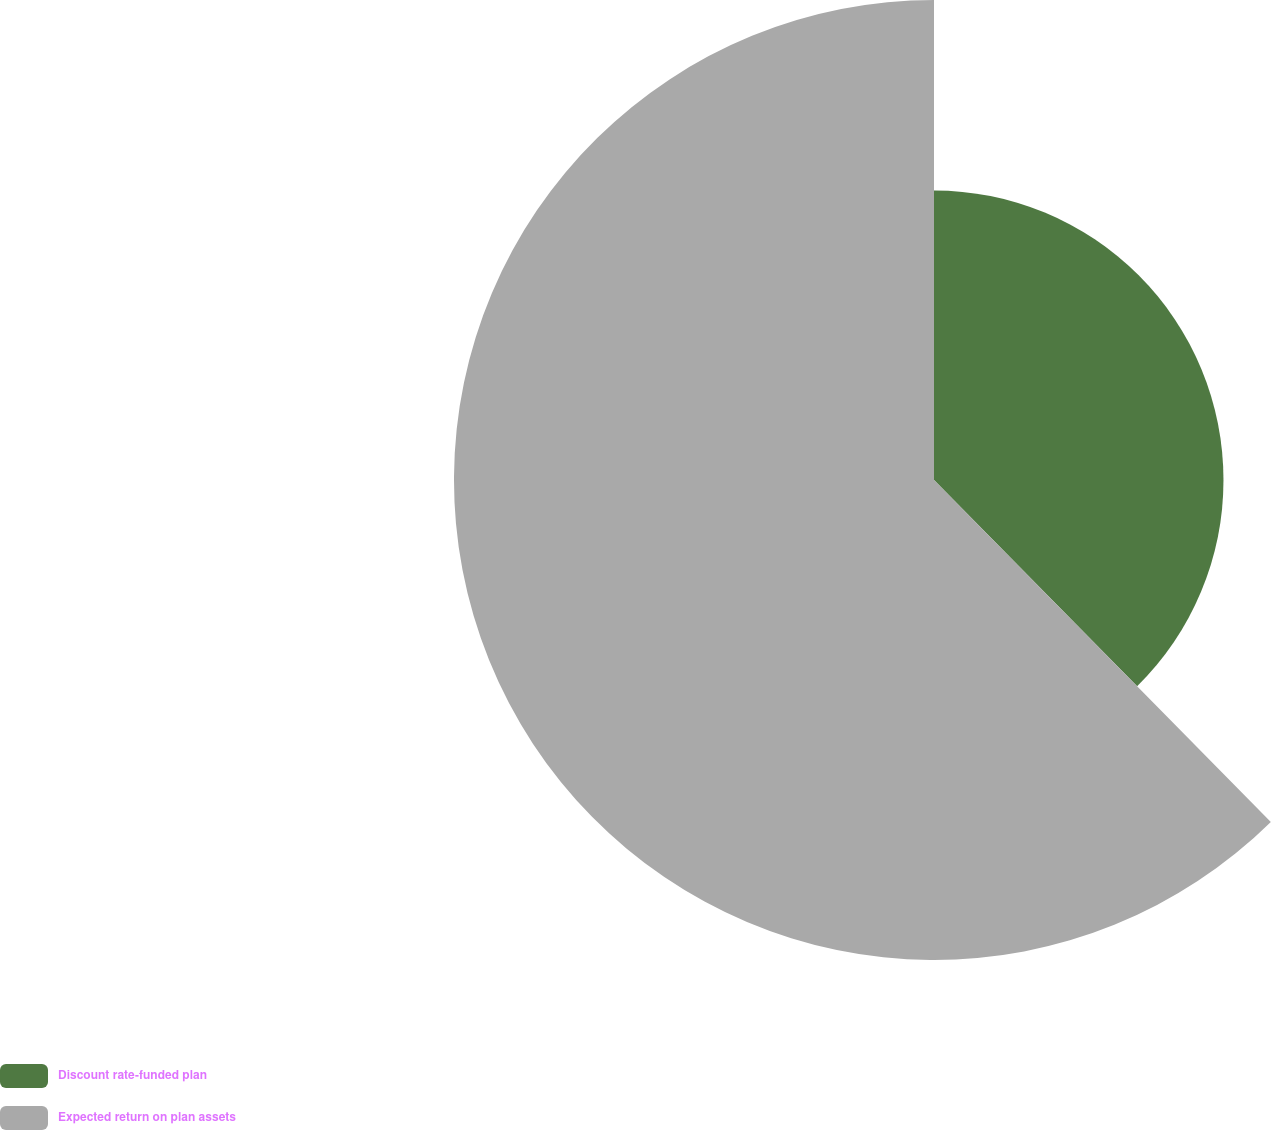Convert chart. <chart><loc_0><loc_0><loc_500><loc_500><pie_chart><fcel>Discount rate-funded plan<fcel>Expected return on plan assets<nl><fcel>37.62%<fcel>62.38%<nl></chart> 